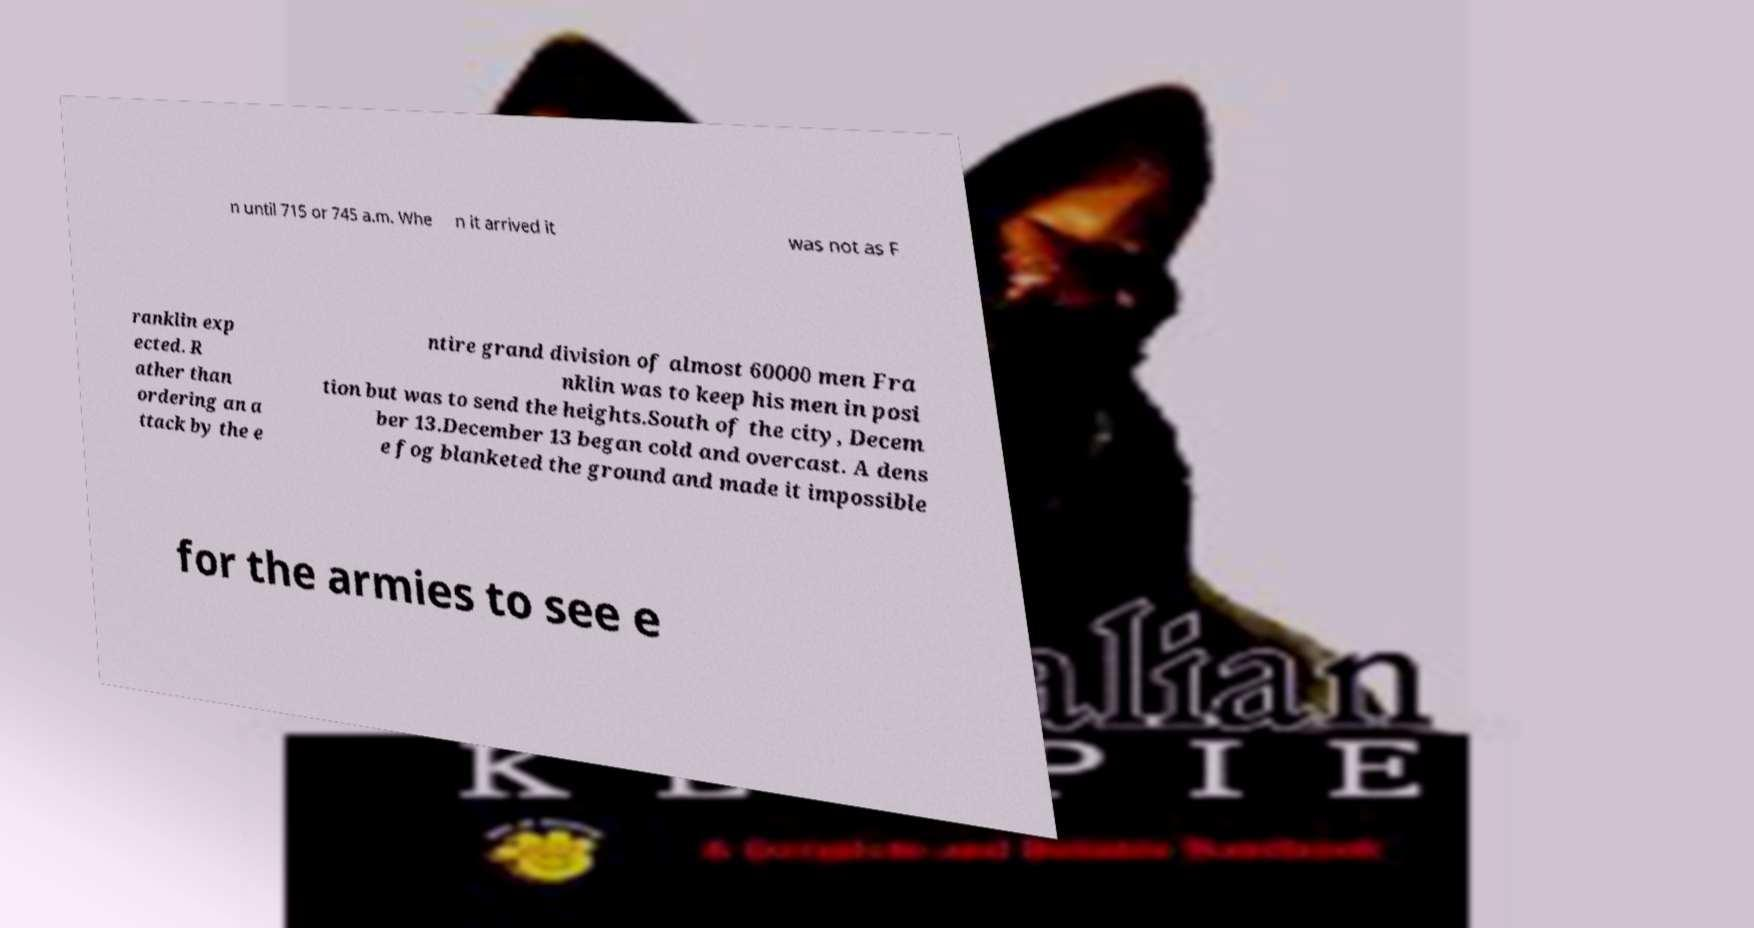Can you accurately transcribe the text from the provided image for me? n until 715 or 745 a.m. Whe n it arrived it was not as F ranklin exp ected. R ather than ordering an a ttack by the e ntire grand division of almost 60000 men Fra nklin was to keep his men in posi tion but was to send the heights.South of the city, Decem ber 13.December 13 began cold and overcast. A dens e fog blanketed the ground and made it impossible for the armies to see e 